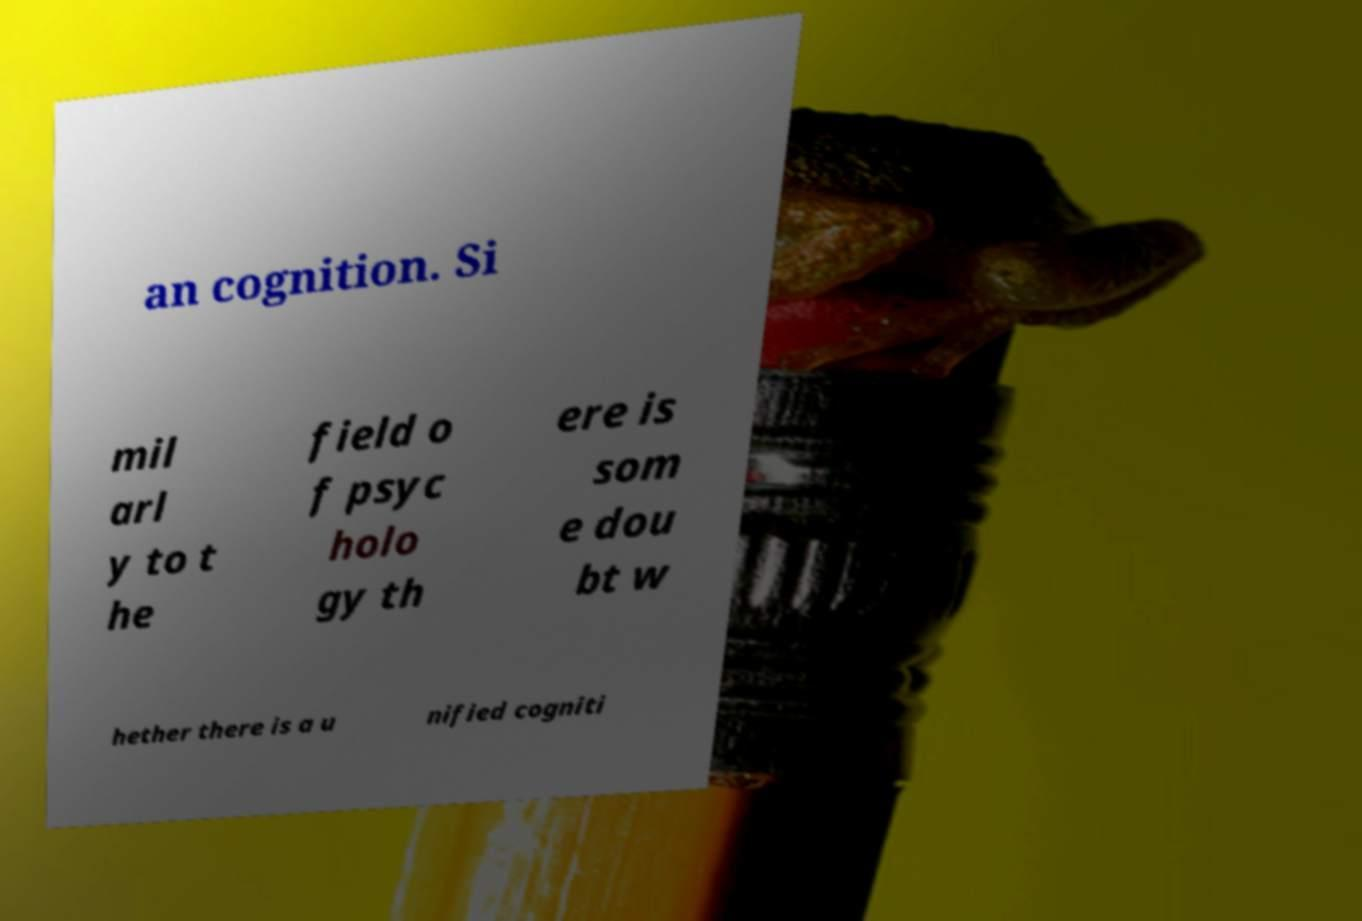For documentation purposes, I need the text within this image transcribed. Could you provide that? an cognition. Si mil arl y to t he field o f psyc holo gy th ere is som e dou bt w hether there is a u nified cogniti 